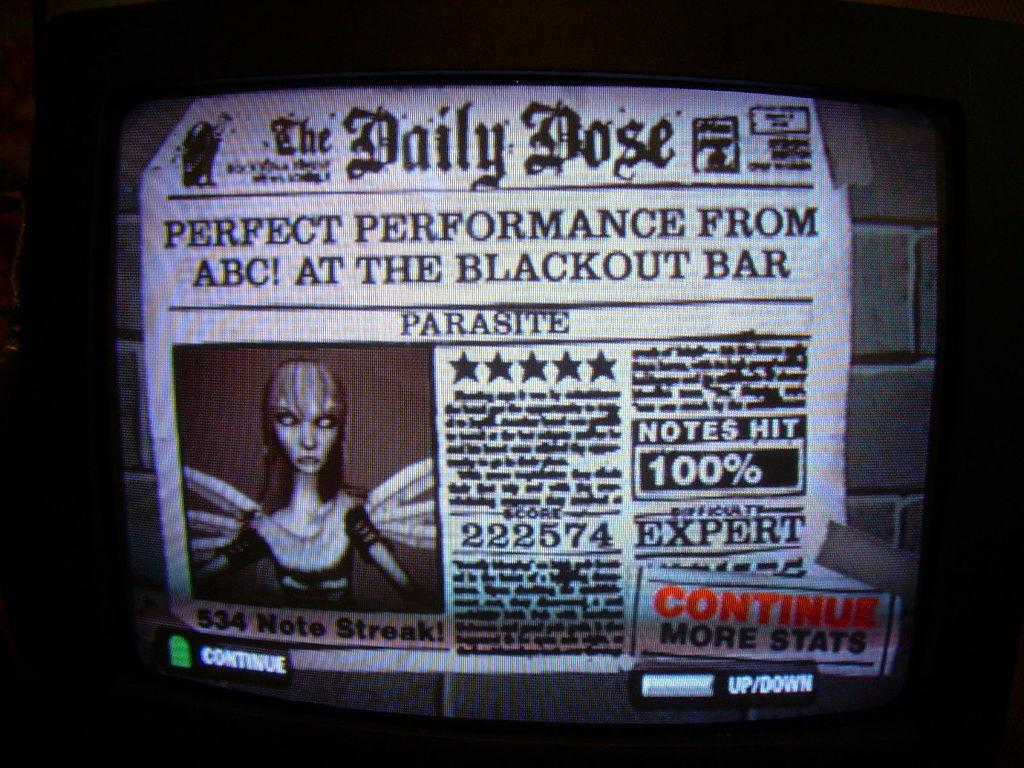What is the main object in the image? There is a television screen in the image. What is displayed on the television screen? The television screen displays a newspaper. What can be found within the newspaper? The newspaper contains words and numbers. Is there any visual element in the newspaper? Yes, the newspaper has a cartoon image. Where is the newspaper located in the image? The newspaper is attached to a wall. Can you see a goat shaking a drop of water off its fur in the image? No, there is no goat or any water-related activity in the image. 